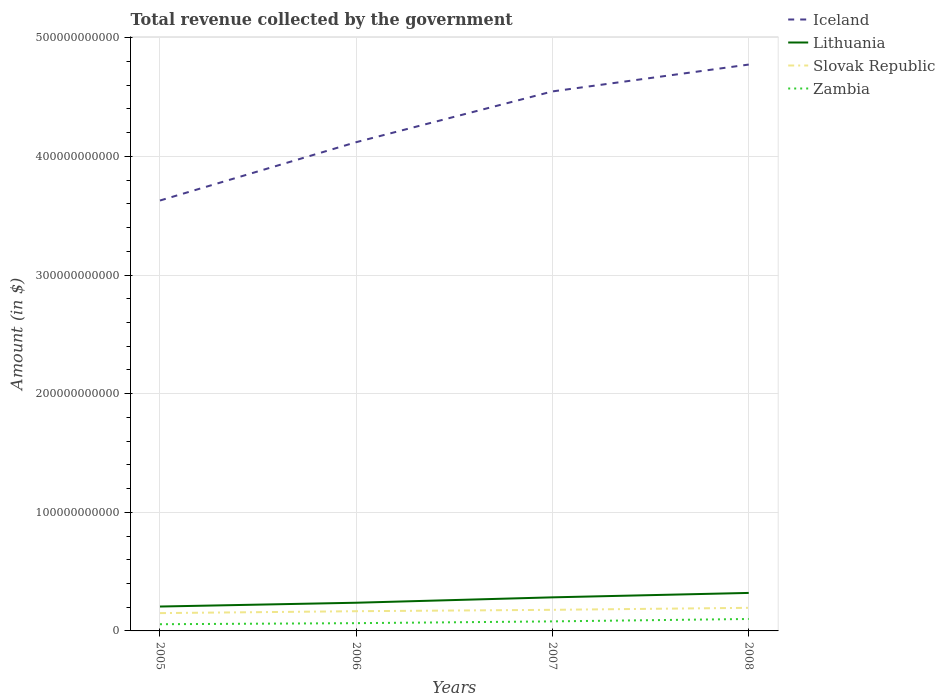Does the line corresponding to Zambia intersect with the line corresponding to Lithuania?
Your response must be concise. No. Across all years, what is the maximum total revenue collected by the government in Lithuania?
Offer a terse response. 2.06e+1. In which year was the total revenue collected by the government in Zambia maximum?
Your answer should be very brief. 2005. What is the total total revenue collected by the government in Slovak Republic in the graph?
Give a very brief answer. -1.17e+09. What is the difference between the highest and the second highest total revenue collected by the government in Zambia?
Keep it short and to the point. 4.42e+09. Is the total revenue collected by the government in Slovak Republic strictly greater than the total revenue collected by the government in Zambia over the years?
Provide a short and direct response. No. How many lines are there?
Your answer should be compact. 4. How many years are there in the graph?
Make the answer very short. 4. What is the difference between two consecutive major ticks on the Y-axis?
Offer a terse response. 1.00e+11. How are the legend labels stacked?
Your answer should be compact. Vertical. What is the title of the graph?
Ensure brevity in your answer.  Total revenue collected by the government. What is the label or title of the Y-axis?
Your response must be concise. Amount (in $). What is the Amount (in $) in Iceland in 2005?
Your answer should be compact. 3.63e+11. What is the Amount (in $) in Lithuania in 2005?
Ensure brevity in your answer.  2.06e+1. What is the Amount (in $) in Slovak Republic in 2005?
Provide a succinct answer. 1.50e+1. What is the Amount (in $) in Zambia in 2005?
Ensure brevity in your answer.  5.65e+09. What is the Amount (in $) in Iceland in 2006?
Ensure brevity in your answer.  4.12e+11. What is the Amount (in $) of Lithuania in 2006?
Make the answer very short. 2.38e+1. What is the Amount (in $) in Slovak Republic in 2006?
Provide a succinct answer. 1.66e+1. What is the Amount (in $) of Zambia in 2006?
Keep it short and to the point. 6.54e+09. What is the Amount (in $) of Iceland in 2007?
Your answer should be very brief. 4.55e+11. What is the Amount (in $) in Lithuania in 2007?
Give a very brief answer. 2.83e+1. What is the Amount (in $) of Slovak Republic in 2007?
Offer a terse response. 1.78e+1. What is the Amount (in $) of Zambia in 2007?
Provide a short and direct response. 8.04e+09. What is the Amount (in $) of Iceland in 2008?
Offer a terse response. 4.77e+11. What is the Amount (in $) in Lithuania in 2008?
Ensure brevity in your answer.  3.20e+1. What is the Amount (in $) of Slovak Republic in 2008?
Keep it short and to the point. 1.95e+1. What is the Amount (in $) of Zambia in 2008?
Give a very brief answer. 1.01e+1. Across all years, what is the maximum Amount (in $) in Iceland?
Your response must be concise. 4.77e+11. Across all years, what is the maximum Amount (in $) in Lithuania?
Provide a short and direct response. 3.20e+1. Across all years, what is the maximum Amount (in $) in Slovak Republic?
Keep it short and to the point. 1.95e+1. Across all years, what is the maximum Amount (in $) in Zambia?
Provide a short and direct response. 1.01e+1. Across all years, what is the minimum Amount (in $) in Iceland?
Your response must be concise. 3.63e+11. Across all years, what is the minimum Amount (in $) of Lithuania?
Ensure brevity in your answer.  2.06e+1. Across all years, what is the minimum Amount (in $) in Slovak Republic?
Your answer should be very brief. 1.50e+1. Across all years, what is the minimum Amount (in $) of Zambia?
Keep it short and to the point. 5.65e+09. What is the total Amount (in $) of Iceland in the graph?
Make the answer very short. 1.71e+12. What is the total Amount (in $) in Lithuania in the graph?
Keep it short and to the point. 1.05e+11. What is the total Amount (in $) of Slovak Republic in the graph?
Your answer should be very brief. 6.89e+1. What is the total Amount (in $) of Zambia in the graph?
Give a very brief answer. 3.03e+1. What is the difference between the Amount (in $) in Iceland in 2005 and that in 2006?
Offer a terse response. -4.92e+1. What is the difference between the Amount (in $) in Lithuania in 2005 and that in 2006?
Your response must be concise. -3.21e+09. What is the difference between the Amount (in $) of Slovak Republic in 2005 and that in 2006?
Your response must be concise. -1.61e+09. What is the difference between the Amount (in $) of Zambia in 2005 and that in 2006?
Provide a short and direct response. -8.90e+08. What is the difference between the Amount (in $) in Iceland in 2005 and that in 2007?
Ensure brevity in your answer.  -9.20e+1. What is the difference between the Amount (in $) of Lithuania in 2005 and that in 2007?
Give a very brief answer. -7.75e+09. What is the difference between the Amount (in $) in Slovak Republic in 2005 and that in 2007?
Keep it short and to the point. -2.77e+09. What is the difference between the Amount (in $) in Zambia in 2005 and that in 2007?
Ensure brevity in your answer.  -2.38e+09. What is the difference between the Amount (in $) in Iceland in 2005 and that in 2008?
Provide a short and direct response. -1.15e+11. What is the difference between the Amount (in $) in Lithuania in 2005 and that in 2008?
Your answer should be very brief. -1.15e+1. What is the difference between the Amount (in $) in Slovak Republic in 2005 and that in 2008?
Your response must be concise. -4.46e+09. What is the difference between the Amount (in $) of Zambia in 2005 and that in 2008?
Provide a short and direct response. -4.42e+09. What is the difference between the Amount (in $) in Iceland in 2006 and that in 2007?
Keep it short and to the point. -4.28e+1. What is the difference between the Amount (in $) of Lithuania in 2006 and that in 2007?
Ensure brevity in your answer.  -4.54e+09. What is the difference between the Amount (in $) of Slovak Republic in 2006 and that in 2007?
Your response must be concise. -1.17e+09. What is the difference between the Amount (in $) of Zambia in 2006 and that in 2007?
Offer a terse response. -1.49e+09. What is the difference between the Amount (in $) of Iceland in 2006 and that in 2008?
Provide a short and direct response. -6.54e+1. What is the difference between the Amount (in $) of Lithuania in 2006 and that in 2008?
Your answer should be compact. -8.26e+09. What is the difference between the Amount (in $) in Slovak Republic in 2006 and that in 2008?
Offer a terse response. -2.85e+09. What is the difference between the Amount (in $) of Zambia in 2006 and that in 2008?
Offer a very short reply. -3.53e+09. What is the difference between the Amount (in $) in Iceland in 2007 and that in 2008?
Provide a succinct answer. -2.26e+1. What is the difference between the Amount (in $) in Lithuania in 2007 and that in 2008?
Ensure brevity in your answer.  -3.72e+09. What is the difference between the Amount (in $) in Slovak Republic in 2007 and that in 2008?
Give a very brief answer. -1.69e+09. What is the difference between the Amount (in $) in Zambia in 2007 and that in 2008?
Keep it short and to the point. -2.04e+09. What is the difference between the Amount (in $) of Iceland in 2005 and the Amount (in $) of Lithuania in 2006?
Make the answer very short. 3.39e+11. What is the difference between the Amount (in $) of Iceland in 2005 and the Amount (in $) of Slovak Republic in 2006?
Offer a terse response. 3.46e+11. What is the difference between the Amount (in $) of Iceland in 2005 and the Amount (in $) of Zambia in 2006?
Your answer should be very brief. 3.56e+11. What is the difference between the Amount (in $) in Lithuania in 2005 and the Amount (in $) in Slovak Republic in 2006?
Provide a succinct answer. 3.94e+09. What is the difference between the Amount (in $) of Lithuania in 2005 and the Amount (in $) of Zambia in 2006?
Make the answer very short. 1.40e+1. What is the difference between the Amount (in $) of Slovak Republic in 2005 and the Amount (in $) of Zambia in 2006?
Make the answer very short. 8.47e+09. What is the difference between the Amount (in $) in Iceland in 2005 and the Amount (in $) in Lithuania in 2007?
Keep it short and to the point. 3.35e+11. What is the difference between the Amount (in $) of Iceland in 2005 and the Amount (in $) of Slovak Republic in 2007?
Ensure brevity in your answer.  3.45e+11. What is the difference between the Amount (in $) of Iceland in 2005 and the Amount (in $) of Zambia in 2007?
Offer a very short reply. 3.55e+11. What is the difference between the Amount (in $) of Lithuania in 2005 and the Amount (in $) of Slovak Republic in 2007?
Offer a terse response. 2.77e+09. What is the difference between the Amount (in $) of Lithuania in 2005 and the Amount (in $) of Zambia in 2007?
Your answer should be compact. 1.25e+1. What is the difference between the Amount (in $) in Slovak Republic in 2005 and the Amount (in $) in Zambia in 2007?
Make the answer very short. 6.98e+09. What is the difference between the Amount (in $) of Iceland in 2005 and the Amount (in $) of Lithuania in 2008?
Your response must be concise. 3.31e+11. What is the difference between the Amount (in $) in Iceland in 2005 and the Amount (in $) in Slovak Republic in 2008?
Your answer should be very brief. 3.43e+11. What is the difference between the Amount (in $) in Iceland in 2005 and the Amount (in $) in Zambia in 2008?
Give a very brief answer. 3.53e+11. What is the difference between the Amount (in $) of Lithuania in 2005 and the Amount (in $) of Slovak Republic in 2008?
Make the answer very short. 1.09e+09. What is the difference between the Amount (in $) in Lithuania in 2005 and the Amount (in $) in Zambia in 2008?
Offer a very short reply. 1.05e+1. What is the difference between the Amount (in $) in Slovak Republic in 2005 and the Amount (in $) in Zambia in 2008?
Your answer should be very brief. 4.94e+09. What is the difference between the Amount (in $) in Iceland in 2006 and the Amount (in $) in Lithuania in 2007?
Your response must be concise. 3.84e+11. What is the difference between the Amount (in $) in Iceland in 2006 and the Amount (in $) in Slovak Republic in 2007?
Offer a terse response. 3.94e+11. What is the difference between the Amount (in $) of Iceland in 2006 and the Amount (in $) of Zambia in 2007?
Make the answer very short. 4.04e+11. What is the difference between the Amount (in $) of Lithuania in 2006 and the Amount (in $) of Slovak Republic in 2007?
Your answer should be compact. 5.98e+09. What is the difference between the Amount (in $) in Lithuania in 2006 and the Amount (in $) in Zambia in 2007?
Provide a short and direct response. 1.57e+1. What is the difference between the Amount (in $) of Slovak Republic in 2006 and the Amount (in $) of Zambia in 2007?
Your answer should be compact. 8.58e+09. What is the difference between the Amount (in $) of Iceland in 2006 and the Amount (in $) of Lithuania in 2008?
Keep it short and to the point. 3.80e+11. What is the difference between the Amount (in $) of Iceland in 2006 and the Amount (in $) of Slovak Republic in 2008?
Provide a short and direct response. 3.93e+11. What is the difference between the Amount (in $) of Iceland in 2006 and the Amount (in $) of Zambia in 2008?
Offer a terse response. 4.02e+11. What is the difference between the Amount (in $) of Lithuania in 2006 and the Amount (in $) of Slovak Republic in 2008?
Offer a terse response. 4.29e+09. What is the difference between the Amount (in $) of Lithuania in 2006 and the Amount (in $) of Zambia in 2008?
Offer a terse response. 1.37e+1. What is the difference between the Amount (in $) in Slovak Republic in 2006 and the Amount (in $) in Zambia in 2008?
Keep it short and to the point. 6.55e+09. What is the difference between the Amount (in $) in Iceland in 2007 and the Amount (in $) in Lithuania in 2008?
Ensure brevity in your answer.  4.23e+11. What is the difference between the Amount (in $) in Iceland in 2007 and the Amount (in $) in Slovak Republic in 2008?
Your answer should be very brief. 4.35e+11. What is the difference between the Amount (in $) in Iceland in 2007 and the Amount (in $) in Zambia in 2008?
Offer a very short reply. 4.45e+11. What is the difference between the Amount (in $) in Lithuania in 2007 and the Amount (in $) in Slovak Republic in 2008?
Make the answer very short. 8.83e+09. What is the difference between the Amount (in $) in Lithuania in 2007 and the Amount (in $) in Zambia in 2008?
Ensure brevity in your answer.  1.82e+1. What is the difference between the Amount (in $) in Slovak Republic in 2007 and the Amount (in $) in Zambia in 2008?
Offer a terse response. 7.71e+09. What is the average Amount (in $) in Iceland per year?
Offer a terse response. 4.27e+11. What is the average Amount (in $) of Lithuania per year?
Your response must be concise. 2.62e+1. What is the average Amount (in $) in Slovak Republic per year?
Provide a short and direct response. 1.72e+1. What is the average Amount (in $) of Zambia per year?
Make the answer very short. 7.58e+09. In the year 2005, what is the difference between the Amount (in $) in Iceland and Amount (in $) in Lithuania?
Offer a very short reply. 3.42e+11. In the year 2005, what is the difference between the Amount (in $) in Iceland and Amount (in $) in Slovak Republic?
Give a very brief answer. 3.48e+11. In the year 2005, what is the difference between the Amount (in $) of Iceland and Amount (in $) of Zambia?
Provide a succinct answer. 3.57e+11. In the year 2005, what is the difference between the Amount (in $) of Lithuania and Amount (in $) of Slovak Republic?
Keep it short and to the point. 5.55e+09. In the year 2005, what is the difference between the Amount (in $) in Lithuania and Amount (in $) in Zambia?
Make the answer very short. 1.49e+1. In the year 2005, what is the difference between the Amount (in $) of Slovak Republic and Amount (in $) of Zambia?
Give a very brief answer. 9.36e+09. In the year 2006, what is the difference between the Amount (in $) in Iceland and Amount (in $) in Lithuania?
Provide a succinct answer. 3.88e+11. In the year 2006, what is the difference between the Amount (in $) in Iceland and Amount (in $) in Slovak Republic?
Provide a short and direct response. 3.95e+11. In the year 2006, what is the difference between the Amount (in $) of Iceland and Amount (in $) of Zambia?
Your answer should be very brief. 4.05e+11. In the year 2006, what is the difference between the Amount (in $) of Lithuania and Amount (in $) of Slovak Republic?
Ensure brevity in your answer.  7.14e+09. In the year 2006, what is the difference between the Amount (in $) of Lithuania and Amount (in $) of Zambia?
Ensure brevity in your answer.  1.72e+1. In the year 2006, what is the difference between the Amount (in $) in Slovak Republic and Amount (in $) in Zambia?
Keep it short and to the point. 1.01e+1. In the year 2007, what is the difference between the Amount (in $) in Iceland and Amount (in $) in Lithuania?
Keep it short and to the point. 4.27e+11. In the year 2007, what is the difference between the Amount (in $) in Iceland and Amount (in $) in Slovak Republic?
Your answer should be compact. 4.37e+11. In the year 2007, what is the difference between the Amount (in $) in Iceland and Amount (in $) in Zambia?
Make the answer very short. 4.47e+11. In the year 2007, what is the difference between the Amount (in $) in Lithuania and Amount (in $) in Slovak Republic?
Give a very brief answer. 1.05e+1. In the year 2007, what is the difference between the Amount (in $) in Lithuania and Amount (in $) in Zambia?
Provide a short and direct response. 2.03e+1. In the year 2007, what is the difference between the Amount (in $) of Slovak Republic and Amount (in $) of Zambia?
Provide a succinct answer. 9.75e+09. In the year 2008, what is the difference between the Amount (in $) in Iceland and Amount (in $) in Lithuania?
Your answer should be compact. 4.45e+11. In the year 2008, what is the difference between the Amount (in $) in Iceland and Amount (in $) in Slovak Republic?
Provide a succinct answer. 4.58e+11. In the year 2008, what is the difference between the Amount (in $) in Iceland and Amount (in $) in Zambia?
Make the answer very short. 4.67e+11. In the year 2008, what is the difference between the Amount (in $) in Lithuania and Amount (in $) in Slovak Republic?
Ensure brevity in your answer.  1.26e+1. In the year 2008, what is the difference between the Amount (in $) of Lithuania and Amount (in $) of Zambia?
Provide a succinct answer. 2.20e+1. In the year 2008, what is the difference between the Amount (in $) in Slovak Republic and Amount (in $) in Zambia?
Make the answer very short. 9.40e+09. What is the ratio of the Amount (in $) in Iceland in 2005 to that in 2006?
Offer a very short reply. 0.88. What is the ratio of the Amount (in $) of Lithuania in 2005 to that in 2006?
Offer a terse response. 0.87. What is the ratio of the Amount (in $) of Slovak Republic in 2005 to that in 2006?
Your answer should be compact. 0.9. What is the ratio of the Amount (in $) in Zambia in 2005 to that in 2006?
Your response must be concise. 0.86. What is the ratio of the Amount (in $) of Iceland in 2005 to that in 2007?
Ensure brevity in your answer.  0.8. What is the ratio of the Amount (in $) of Lithuania in 2005 to that in 2007?
Your answer should be compact. 0.73. What is the ratio of the Amount (in $) of Slovak Republic in 2005 to that in 2007?
Ensure brevity in your answer.  0.84. What is the ratio of the Amount (in $) of Zambia in 2005 to that in 2007?
Provide a succinct answer. 0.7. What is the ratio of the Amount (in $) of Iceland in 2005 to that in 2008?
Your response must be concise. 0.76. What is the ratio of the Amount (in $) of Lithuania in 2005 to that in 2008?
Make the answer very short. 0.64. What is the ratio of the Amount (in $) in Slovak Republic in 2005 to that in 2008?
Provide a short and direct response. 0.77. What is the ratio of the Amount (in $) of Zambia in 2005 to that in 2008?
Ensure brevity in your answer.  0.56. What is the ratio of the Amount (in $) of Iceland in 2006 to that in 2007?
Ensure brevity in your answer.  0.91. What is the ratio of the Amount (in $) in Lithuania in 2006 to that in 2007?
Give a very brief answer. 0.84. What is the ratio of the Amount (in $) in Slovak Republic in 2006 to that in 2007?
Keep it short and to the point. 0.93. What is the ratio of the Amount (in $) in Zambia in 2006 to that in 2007?
Provide a short and direct response. 0.81. What is the ratio of the Amount (in $) in Iceland in 2006 to that in 2008?
Offer a terse response. 0.86. What is the ratio of the Amount (in $) of Lithuania in 2006 to that in 2008?
Make the answer very short. 0.74. What is the ratio of the Amount (in $) in Slovak Republic in 2006 to that in 2008?
Offer a very short reply. 0.85. What is the ratio of the Amount (in $) in Zambia in 2006 to that in 2008?
Your answer should be very brief. 0.65. What is the ratio of the Amount (in $) of Iceland in 2007 to that in 2008?
Your answer should be compact. 0.95. What is the ratio of the Amount (in $) of Lithuania in 2007 to that in 2008?
Your answer should be very brief. 0.88. What is the ratio of the Amount (in $) in Slovak Republic in 2007 to that in 2008?
Your answer should be compact. 0.91. What is the ratio of the Amount (in $) of Zambia in 2007 to that in 2008?
Keep it short and to the point. 0.8. What is the difference between the highest and the second highest Amount (in $) of Iceland?
Give a very brief answer. 2.26e+1. What is the difference between the highest and the second highest Amount (in $) in Lithuania?
Your response must be concise. 3.72e+09. What is the difference between the highest and the second highest Amount (in $) of Slovak Republic?
Offer a terse response. 1.69e+09. What is the difference between the highest and the second highest Amount (in $) of Zambia?
Your answer should be very brief. 2.04e+09. What is the difference between the highest and the lowest Amount (in $) in Iceland?
Offer a terse response. 1.15e+11. What is the difference between the highest and the lowest Amount (in $) in Lithuania?
Provide a short and direct response. 1.15e+1. What is the difference between the highest and the lowest Amount (in $) of Slovak Republic?
Provide a short and direct response. 4.46e+09. What is the difference between the highest and the lowest Amount (in $) of Zambia?
Offer a terse response. 4.42e+09. 